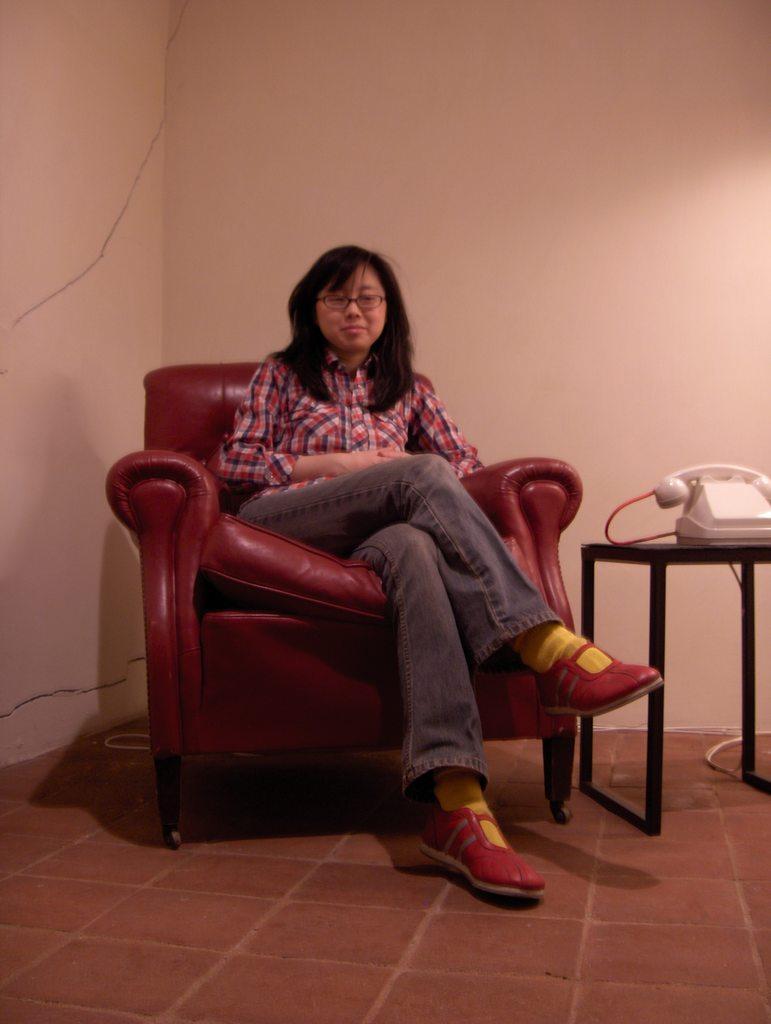In one or two sentences, can you explain what this image depicts? In the image we can see there is a woman who is sitting on a red colour chair and beside her there is a telephone on the table. 